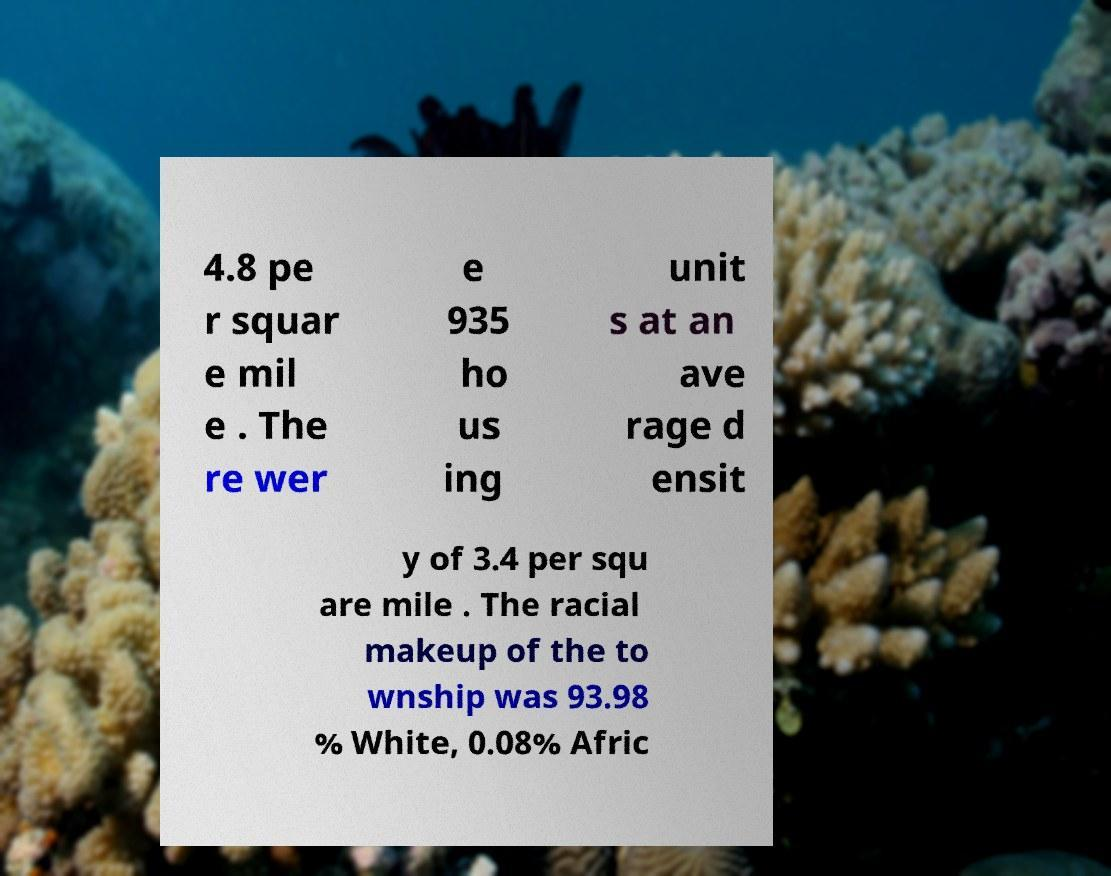Please read and relay the text visible in this image. What does it say? 4.8 pe r squar e mil e . The re wer e 935 ho us ing unit s at an ave rage d ensit y of 3.4 per squ are mile . The racial makeup of the to wnship was 93.98 % White, 0.08% Afric 